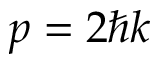<formula> <loc_0><loc_0><loc_500><loc_500>p = 2 \hbar { k }</formula> 